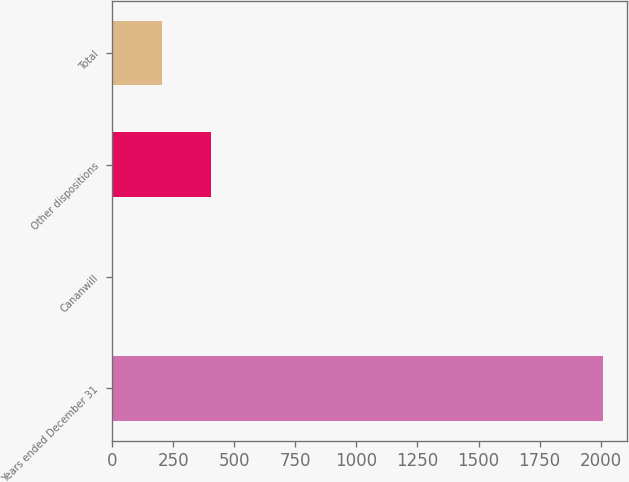Convert chart. <chart><loc_0><loc_0><loc_500><loc_500><bar_chart><fcel>Years ended December 31<fcel>Cananwill<fcel>Other dispositions<fcel>Total<nl><fcel>2009<fcel>2<fcel>403.4<fcel>202.7<nl></chart> 